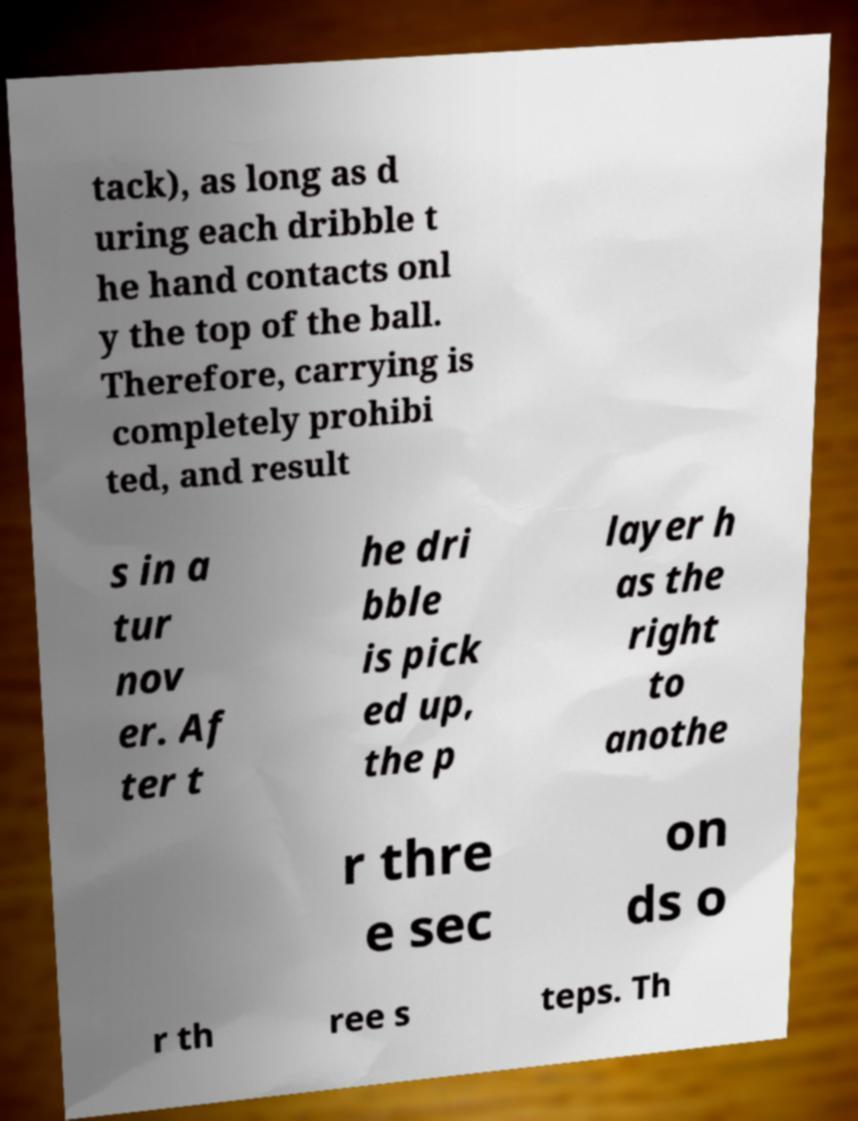Can you accurately transcribe the text from the provided image for me? tack), as long as d uring each dribble t he hand contacts onl y the top of the ball. Therefore, carrying is completely prohibi ted, and result s in a tur nov er. Af ter t he dri bble is pick ed up, the p layer h as the right to anothe r thre e sec on ds o r th ree s teps. Th 